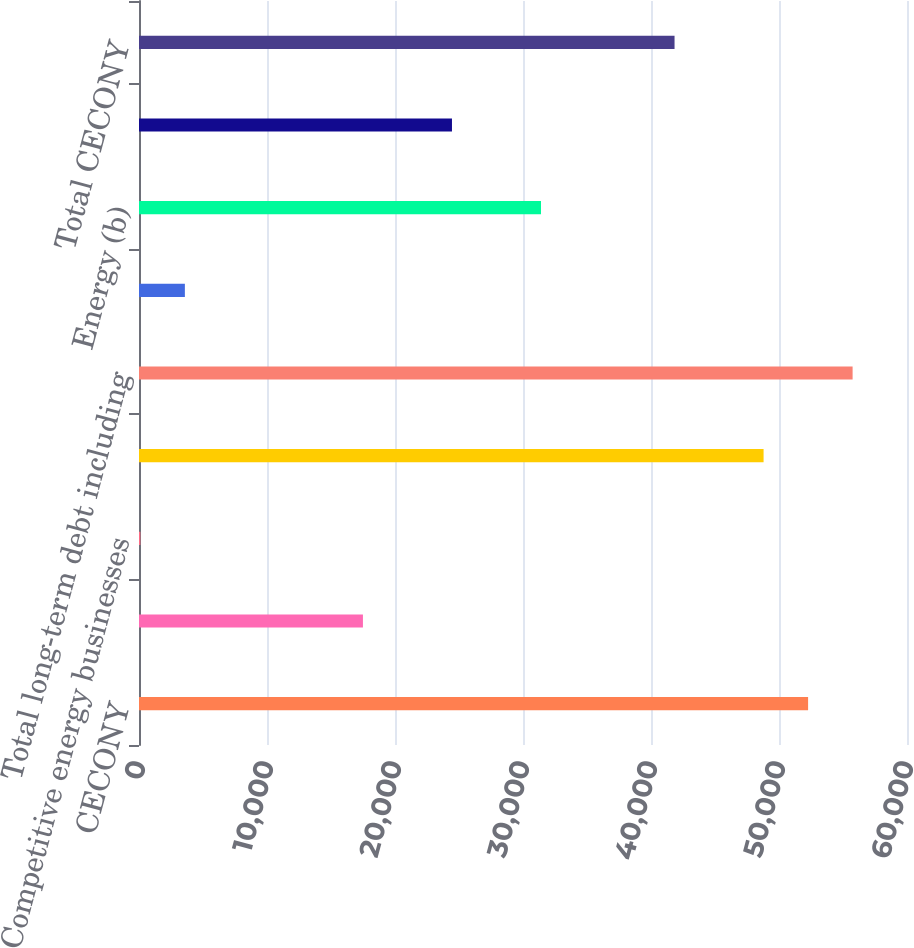<chart> <loc_0><loc_0><loc_500><loc_500><bar_chart><fcel>CECONY<fcel>O&R<fcel>Competitive energy businesses<fcel>Interest on long-term debt (a)<fcel>Total long-term debt including<fcel>Total operating leases<fcel>Energy (b)<fcel>Capacity<fcel>Total CECONY<nl><fcel>52273<fcel>17495<fcel>106<fcel>48795.2<fcel>55750.8<fcel>3583.8<fcel>31406.2<fcel>24450.6<fcel>41839.6<nl></chart> 